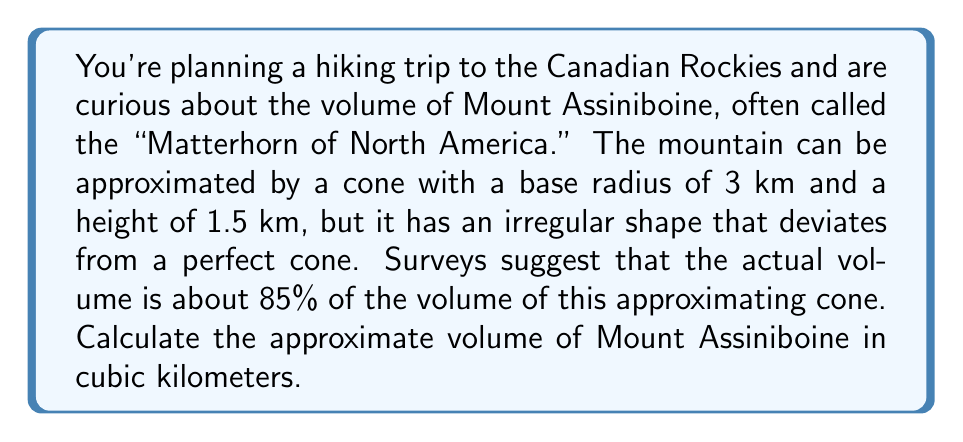Teach me how to tackle this problem. To solve this problem, we'll follow these steps:

1) First, let's recall the formula for the volume of a cone:
   $$V_{cone} = \frac{1}{3}\pi r^2 h$$
   where $r$ is the radius of the base and $h$ is the height.

2) We're given:
   $r = 3$ km
   $h = 1.5$ km

3) Let's calculate the volume of the approximating cone:
   $$V_{cone} = \frac{1}{3}\pi (3\text{ km})^2 (1.5\text{ km})$$
   $$V_{cone} = \frac{1}{3}\pi (9\text{ km}^2) (1.5\text{ km})$$
   $$V_{cone} = \frac{1}{3}\pi (13.5\text{ km}^3)$$
   $$V_{cone} = 4.5\pi\text{ km}^3$$

4) Now, we're told that the actual volume of the mountain is about 85% of this cone's volume. To calculate this, we multiply by 0.85:
   $$V_{mountain} = 0.85 \times 4.5\pi\text{ km}^3$$
   $$V_{mountain} = 3.825\pi\text{ km}^3$$

5) We can leave our answer in terms of $\pi$, or we can calculate an approximate numeric value:
   $$V_{mountain} \approx 3.825 \times 3.14159 \text{ km}^3 \approx 12.02\text{ km}^3$$
Answer: The approximate volume of Mount Assiniboine is $3.825\pi\text{ km}^3$ or about $12.02\text{ km}^3$. 